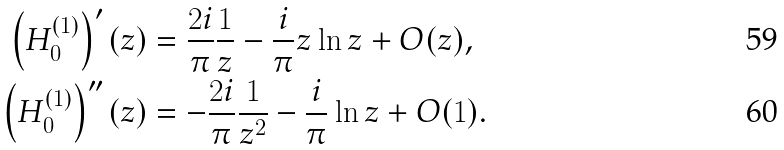<formula> <loc_0><loc_0><loc_500><loc_500>\left ( H _ { 0 } ^ { ( 1 ) } \right ) ^ { \prime } ( z ) & = \frac { 2 i } { \pi } \frac { 1 } { z } - \frac { i } { \pi } z \ln z + O ( z ) , \\ \left ( H _ { 0 } ^ { ( 1 ) } \right ) ^ { \prime \prime } ( z ) & = - \frac { 2 i } { \pi } \frac { 1 } { z ^ { 2 } } - \frac { i } { \pi } \ln z + O ( 1 ) .</formula> 